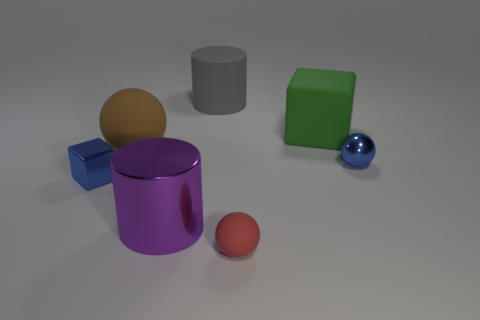Add 3 tiny blue shiny spheres. How many objects exist? 10 Subtract all brown rubber spheres. How many spheres are left? 2 Subtract all spheres. How many objects are left? 4 Subtract all purple spheres. Subtract all yellow blocks. How many spheres are left? 3 Add 6 purple shiny things. How many purple shiny things are left? 7 Add 6 large objects. How many large objects exist? 10 Subtract 1 gray cylinders. How many objects are left? 6 Subtract all brown metallic cubes. Subtract all small blue spheres. How many objects are left? 6 